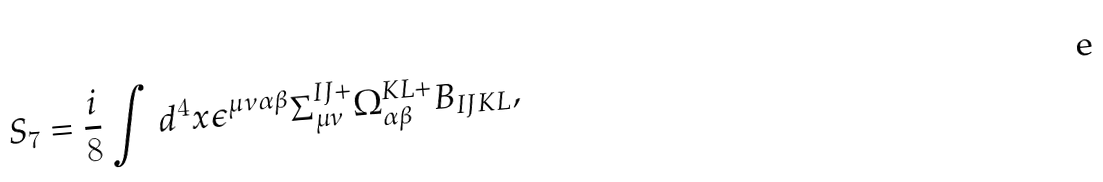Convert formula to latex. <formula><loc_0><loc_0><loc_500><loc_500>S _ { 7 } = \frac { i } { 8 } \int d ^ { 4 } x \epsilon ^ { \mu \nu \alpha \beta } \Sigma _ { \mu \nu } ^ { I J + } \Omega _ { \alpha \beta } ^ { K L + } B _ { I J K L } ,</formula> 